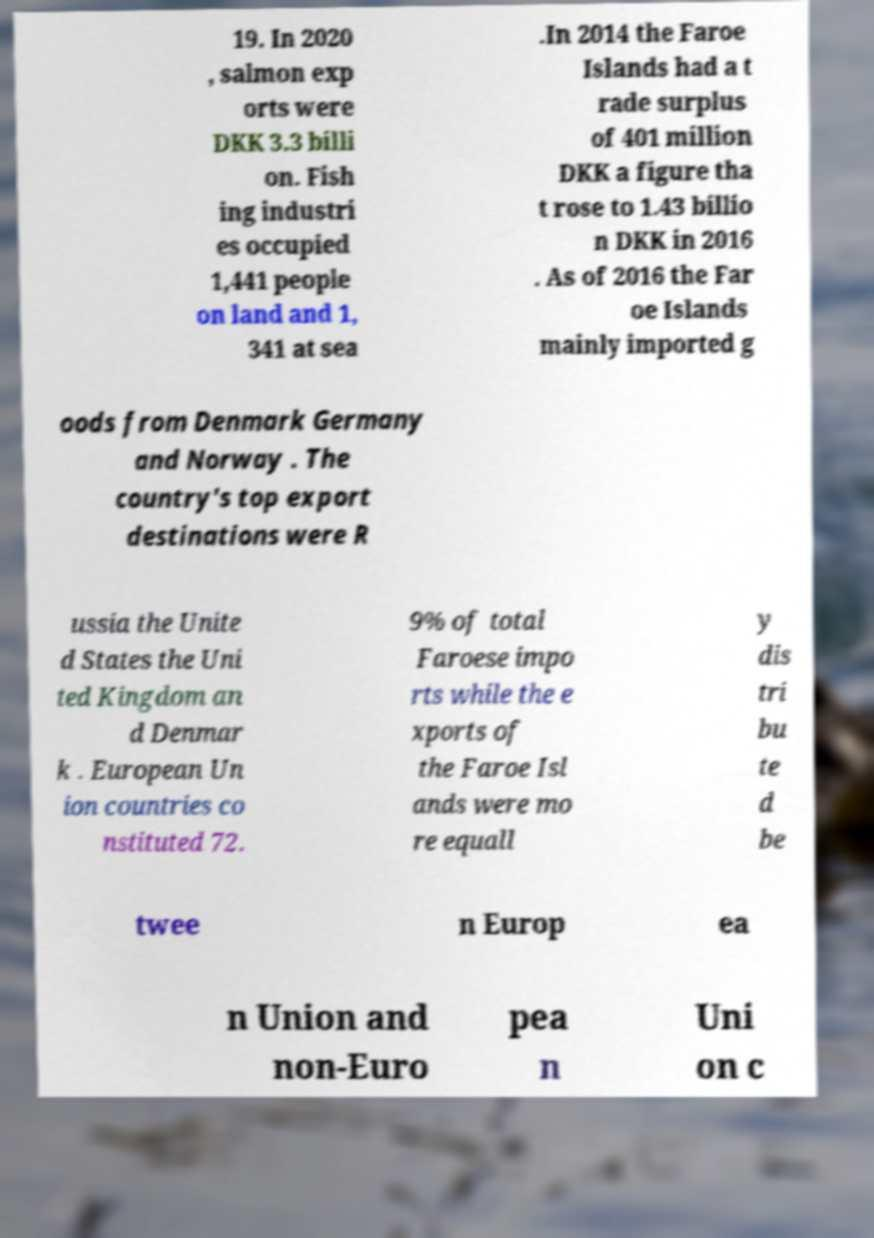Can you read and provide the text displayed in the image?This photo seems to have some interesting text. Can you extract and type it out for me? 19. In 2020 , salmon exp orts were DKK 3.3 billi on. Fish ing industri es occupied 1,441 people on land and 1, 341 at sea .In 2014 the Faroe Islands had a t rade surplus of 401 million DKK a figure tha t rose to 1.43 billio n DKK in 2016 . As of 2016 the Far oe Islands mainly imported g oods from Denmark Germany and Norway . The country's top export destinations were R ussia the Unite d States the Uni ted Kingdom an d Denmar k . European Un ion countries co nstituted 72. 9% of total Faroese impo rts while the e xports of the Faroe Isl ands were mo re equall y dis tri bu te d be twee n Europ ea n Union and non-Euro pea n Uni on c 